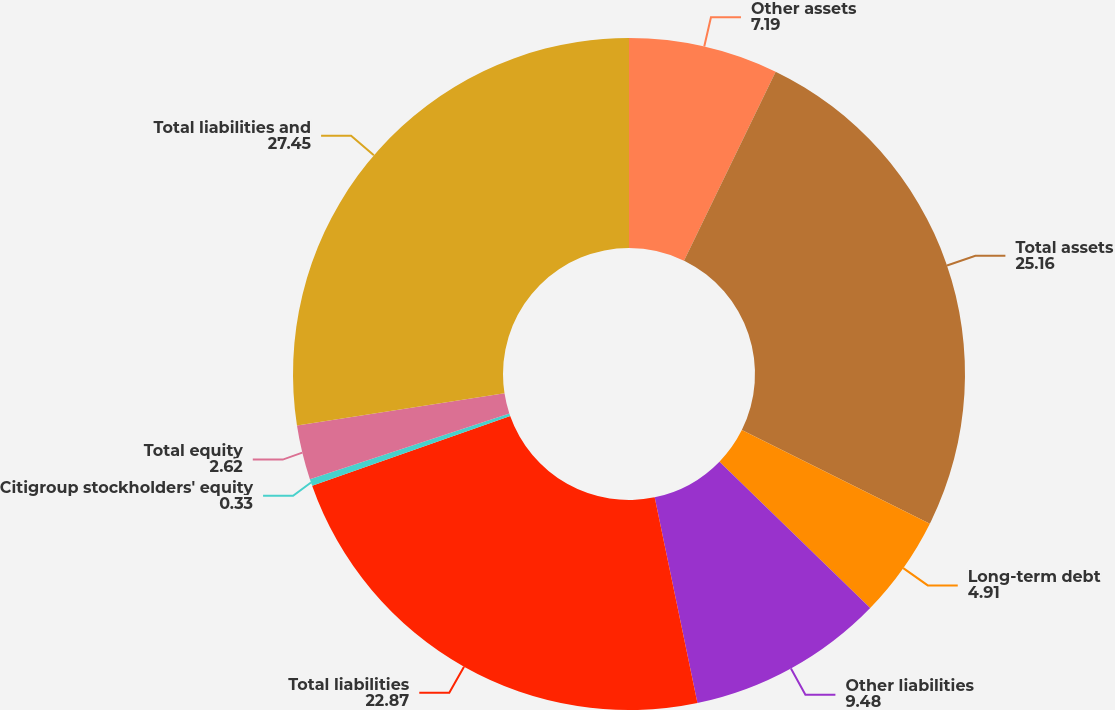Convert chart. <chart><loc_0><loc_0><loc_500><loc_500><pie_chart><fcel>Other assets<fcel>Total assets<fcel>Long-term debt<fcel>Other liabilities<fcel>Total liabilities<fcel>Citigroup stockholders' equity<fcel>Total equity<fcel>Total liabilities and<nl><fcel>7.19%<fcel>25.16%<fcel>4.91%<fcel>9.48%<fcel>22.87%<fcel>0.33%<fcel>2.62%<fcel>27.45%<nl></chart> 